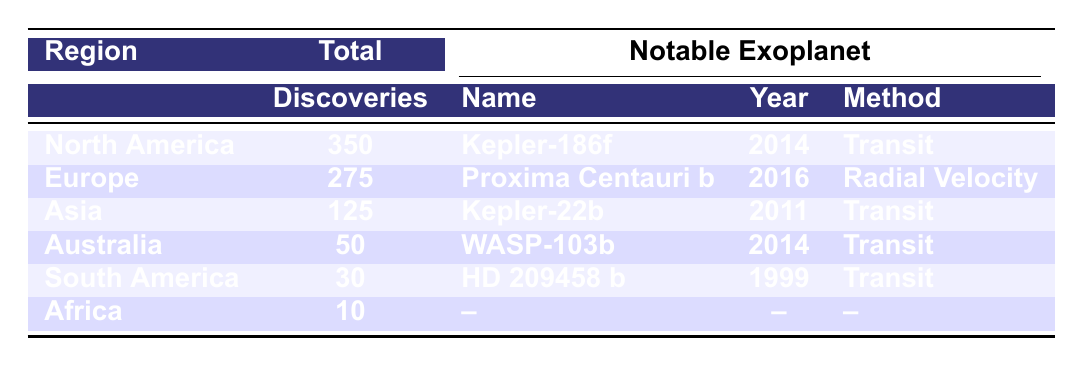What region has the highest number of exoplanet discoveries? The table clearly shows that North America has the highest total discoveries with **350**.
Answer: North America Which exoplanet was discovered in Europe in 2016? The table indicates that **Proxima Centauri b** was discovered in Europe in 2016.
Answer: Proxima Centauri b What is the total number of exoplanet discoveries in Africa? According to the table, Africa has a total of **10** discoveries listed.
Answer: 10 How many exoplanet discoveries are there in South America compared to Australia? South America has **30** discoveries and Australia has **50**. The difference is **50 - 30 = 20**.
Answer: 20 Is there any notable exoplanet listed for Africa? The table shows that Africa has **no** notable exoplanets listed.
Answer: No What is the average number of exoplanet discoveries across the regions listed? The total number of discoveries across all regions is **350 + 275 + 125 + 50 + 30 + 10 = 840**. There are 6 regions, so the average is **840/6 = 140**.
Answer: 140 Out of the notable exoplanets, how many were discovered using the transit method? The notable exoplanets from the table are **Kepler-186f**, **LHS 1140 b**, **Proxima Centauri b**, **TRAPPIST-1e**, **Kepler-22b**, **HD 209458 b**, and **WASP-103b**. Counting, we have **5** that used the transit method.
Answer: 5 What method was used to discover HD 209458 b, and in which region was it discovered? HD 209458 b was discovered using the **transit** method and was listed under **Asia** in the notable exoplanets section.
Answer: Transit, Asia If we exclude North America and Europe, what is the total number of exoplanet discoveries in the other regions? The total for Asia (**125**), Australia (**50**), South America (**30**), and Africa (**10**) is \(125 + 50 + 30 + 10 = 215\).
Answer: 215 